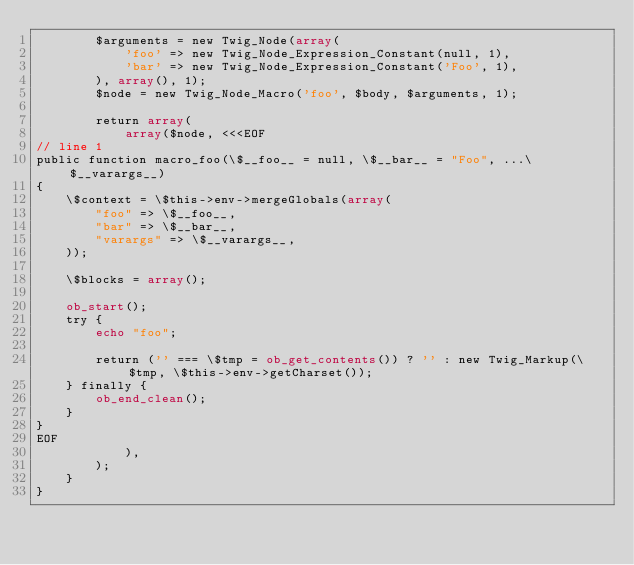Convert code to text. <code><loc_0><loc_0><loc_500><loc_500><_PHP_>        $arguments = new Twig_Node(array(
            'foo' => new Twig_Node_Expression_Constant(null, 1),
            'bar' => new Twig_Node_Expression_Constant('Foo', 1),
        ), array(), 1);
        $node = new Twig_Node_Macro('foo', $body, $arguments, 1);

        return array(
            array($node, <<<EOF
// line 1
public function macro_foo(\$__foo__ = null, \$__bar__ = "Foo", ...\$__varargs__)
{
    \$context = \$this->env->mergeGlobals(array(
        "foo" => \$__foo__,
        "bar" => \$__bar__,
        "varargs" => \$__varargs__,
    ));

    \$blocks = array();

    ob_start();
    try {
        echo "foo";

        return ('' === \$tmp = ob_get_contents()) ? '' : new Twig_Markup(\$tmp, \$this->env->getCharset());
    } finally {
        ob_end_clean();
    }
}
EOF
            ),
        );
    }
}
</code> 